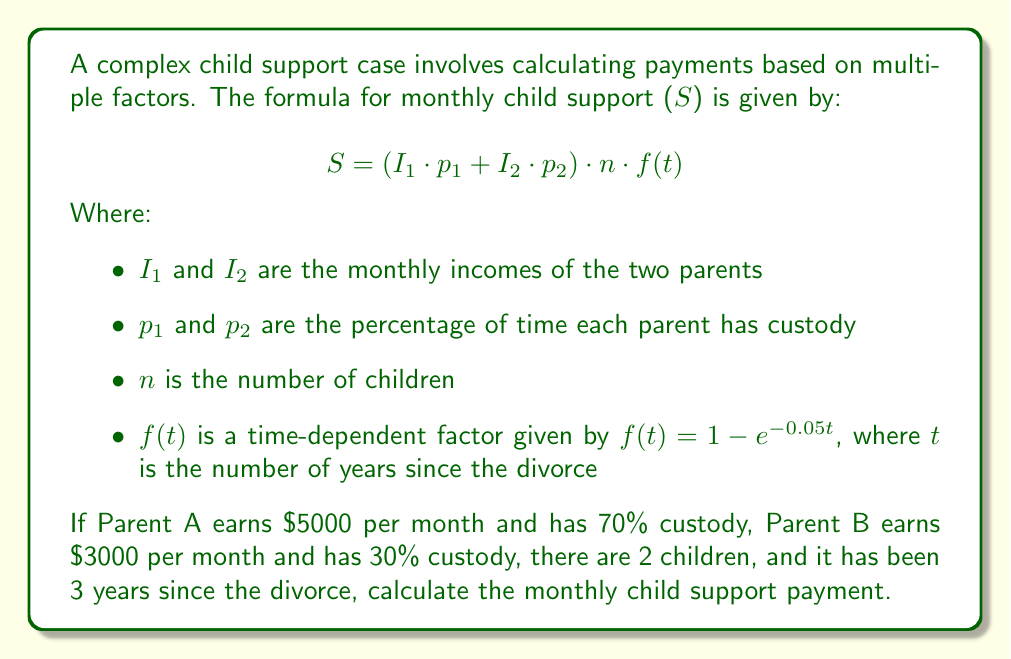Can you answer this question? To solve this problem, we'll follow these steps:

1) First, let's identify our variables:
   $I_1 = 5000$ (Parent A's income)
   $p_1 = 0.70$ (Parent A's custody percentage)
   $I_2 = 3000$ (Parent B's income)
   $p_2 = 0.30$ (Parent B's custody percentage)
   $n = 2$ (number of children)
   $t = 3$ (years since divorce)

2) We need to calculate $f(t)$:
   $f(t) = 1 - e^{-0.05t} = 1 - e^{-0.05 \cdot 3} = 1 - e^{-0.15} \approx 0.1393$

3) Now we can plug these values into our formula:

   $$ S = (I_1 \cdot p_1 + I_2 \cdot p_2) \cdot n \cdot f(t) $$
   $$ S = (5000 \cdot 0.70 + 3000 \cdot 0.30) \cdot 2 \cdot 0.1393 $$

4) Let's solve the parentheses first:
   $5000 \cdot 0.70 = 3500$
   $3000 \cdot 0.30 = 900$
   $3500 + 900 = 4400$

5) Now our equation looks like:
   $$ S = 4400 \cdot 2 \cdot 0.1393 $$

6) Multiplying these numbers:
   $4400 \cdot 2 = 8800$
   $8800 \cdot 0.1393 \approx 1225.84$

Therefore, the monthly child support payment is approximately $1225.84.
Answer: $1225.84 